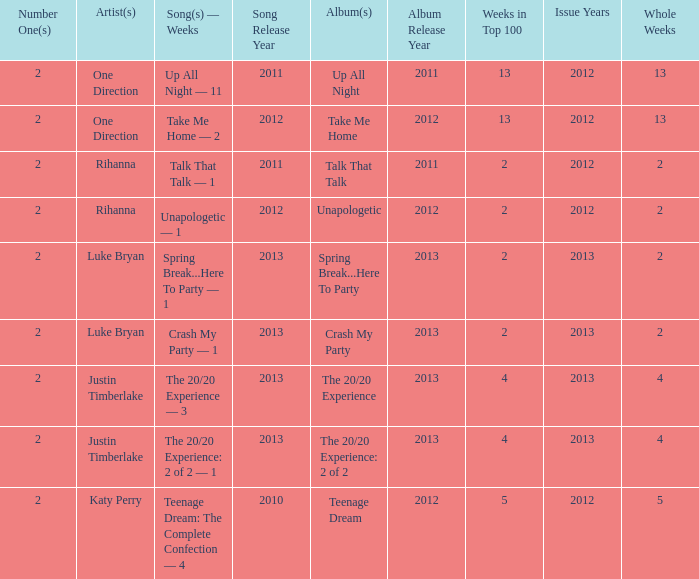What is the title of every song, and how many weeks was each song at #1 for Rihanna in 2012? Talk That Talk — 1, Unapologetic — 1. 